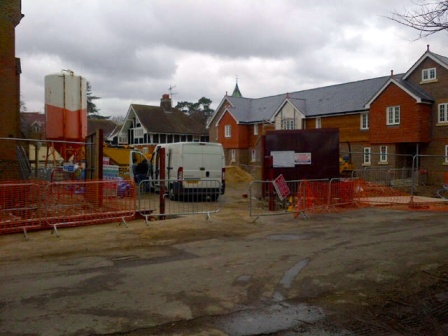What are some potential weather-related challenges this site might face given the current sky conditions? Given the gray, cloudy sky seen in the image, the construction site might be at risk of impending rain, which can significantly delay progress. Rain can cause muddy conditions, making it difficult for vehicles and workers to move around safely. It can also impact the ability to pour concrete, as excess water could weaken it. Additionally, water pooling can create hazardous working conditions, damage materials, and contribute to soil erosion. To mitigate these risks, the site managers might need to implement drainage systems, cover materials, or even pause certain activities until better weather returns. Imagine if a sudden storm hit the site. How would the setting change? As a sudden storm descends upon the construction site, the scene transforms dramatically. The once-bustling site becomes chaotic as workers hastily secure equipment and materials to prevent them from being damaged or blown away. Large droplets begin to pelt against metal surfaces, creating a cacophony of taps and rumbles. Puddles quickly form, turning the dirt ground into thick mud, and making navigation treacherous. The white truck and the vibrant red fence glisten under the relentless downpour, their colors now more pronounced against the gray backdrop. Temporary tarps and coverings flutter wildly in the wind, as site supervisors bark orders to ensure everyone's safety. The entire atmosphere shifts, with the urgency of the storm replacing the methodical pace of construction. 